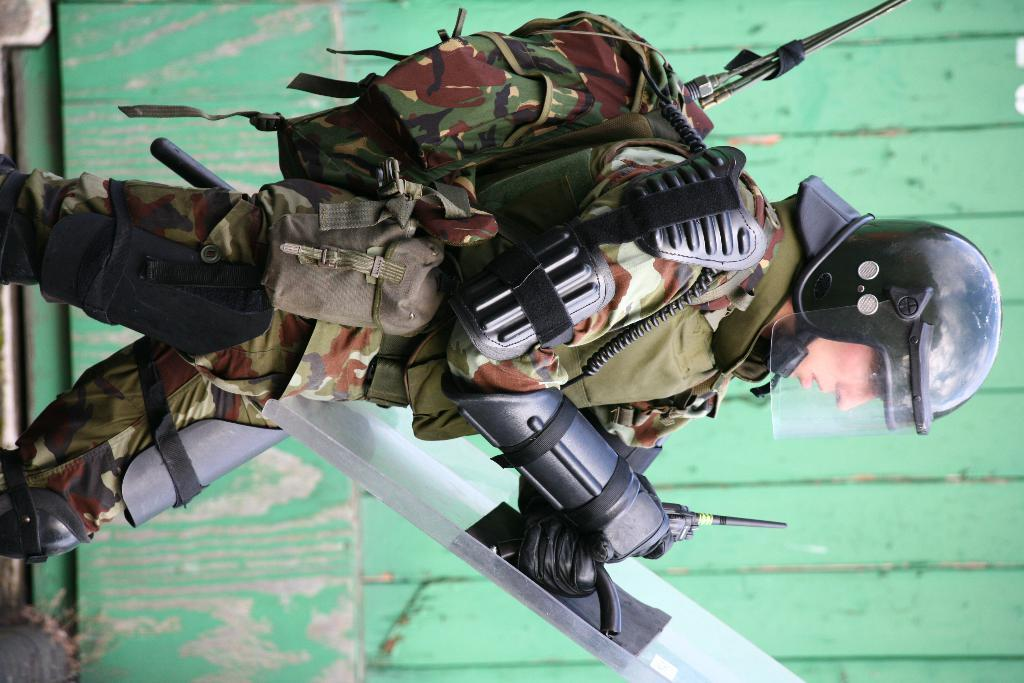What is present in the image? There is a person in the image. What is the person doing in the image? The person is holding an object in his hand. What type of spot can be seen on the person's shirt in the image? There is no spot visible on the person's shirt in the image. What ingredients are used to make the stew that the person is holding in the image? There is no stew present in the image; the person is holding an object, not a stew. Is there a hose visible in the image? There is no hose present in the image. 